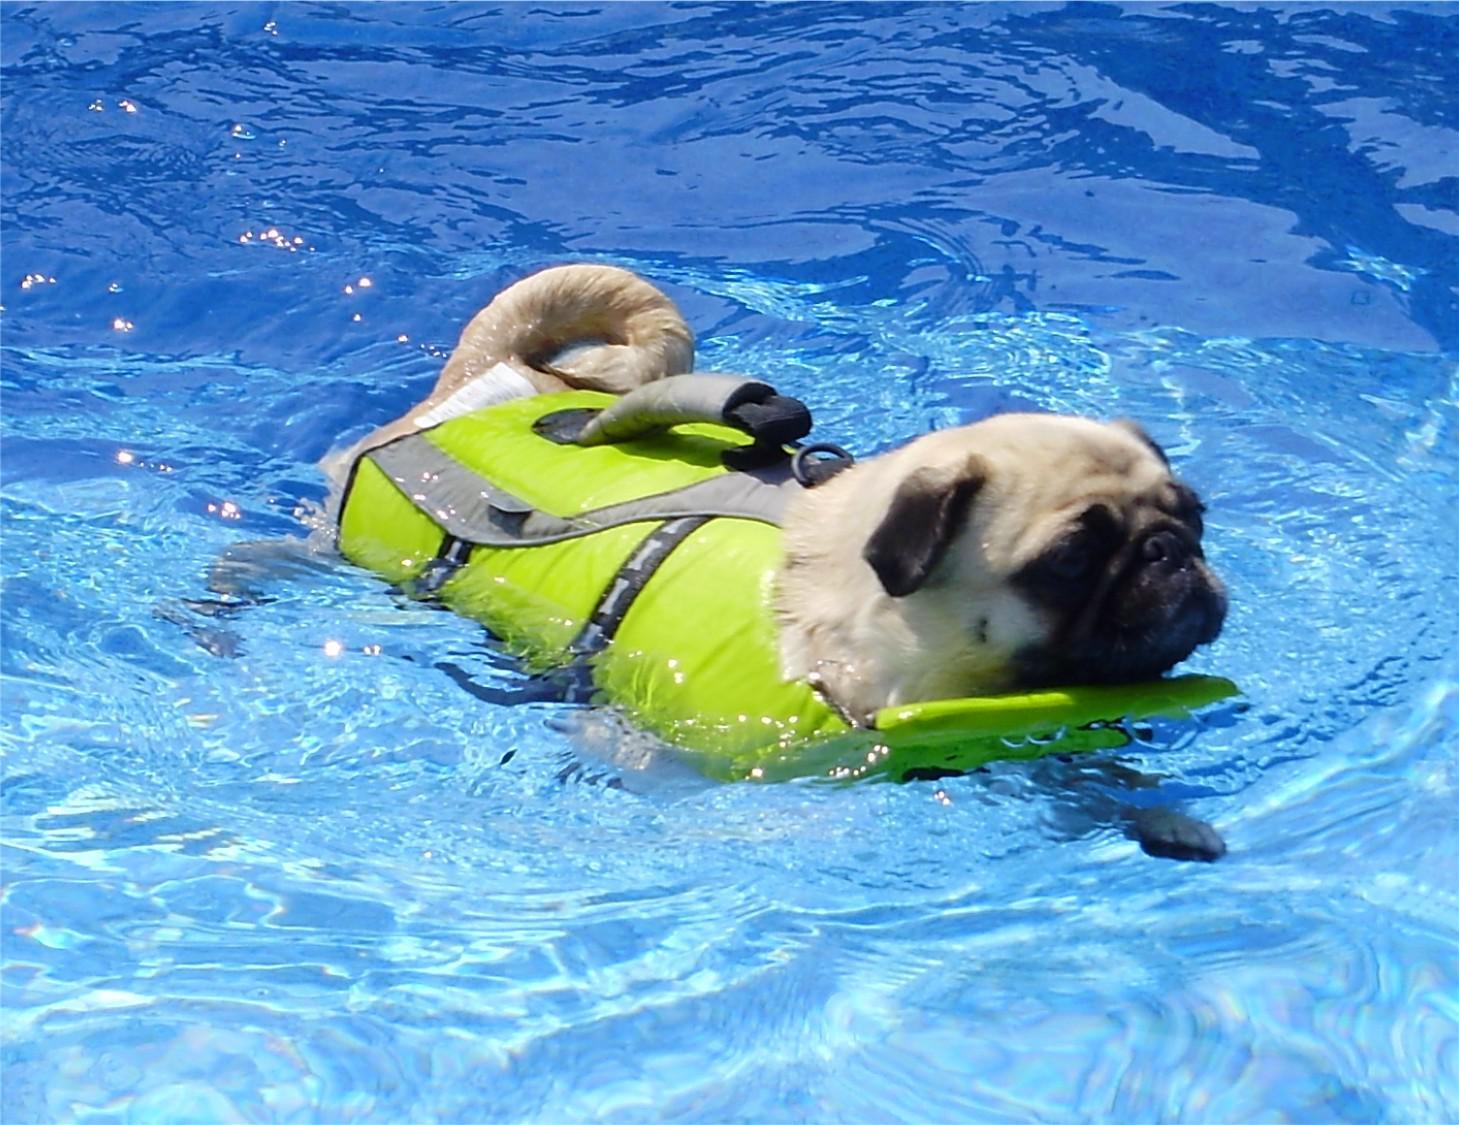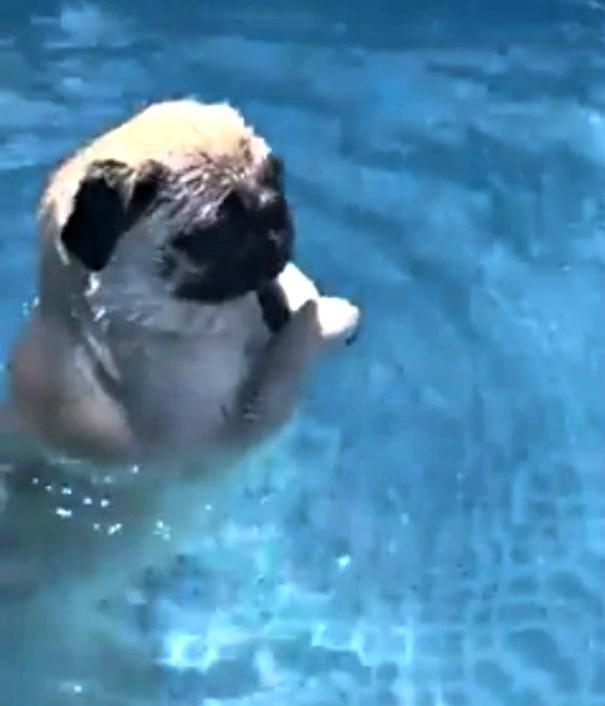The first image is the image on the left, the second image is the image on the right. Analyze the images presented: Is the assertion "A dog is wearing a life vest." valid? Answer yes or no. Yes. The first image is the image on the left, the second image is the image on the right. Analyze the images presented: Is the assertion "There is a pug wearing a life vest." valid? Answer yes or no. Yes. 